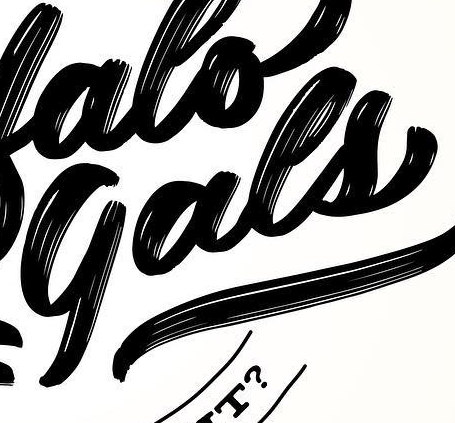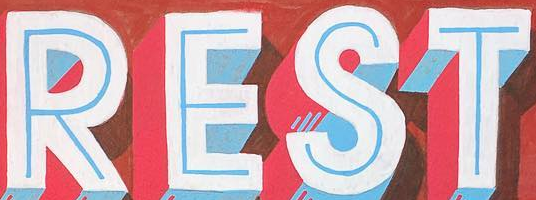What words can you see in these images in sequence, separated by a semicolon? gals; REST 